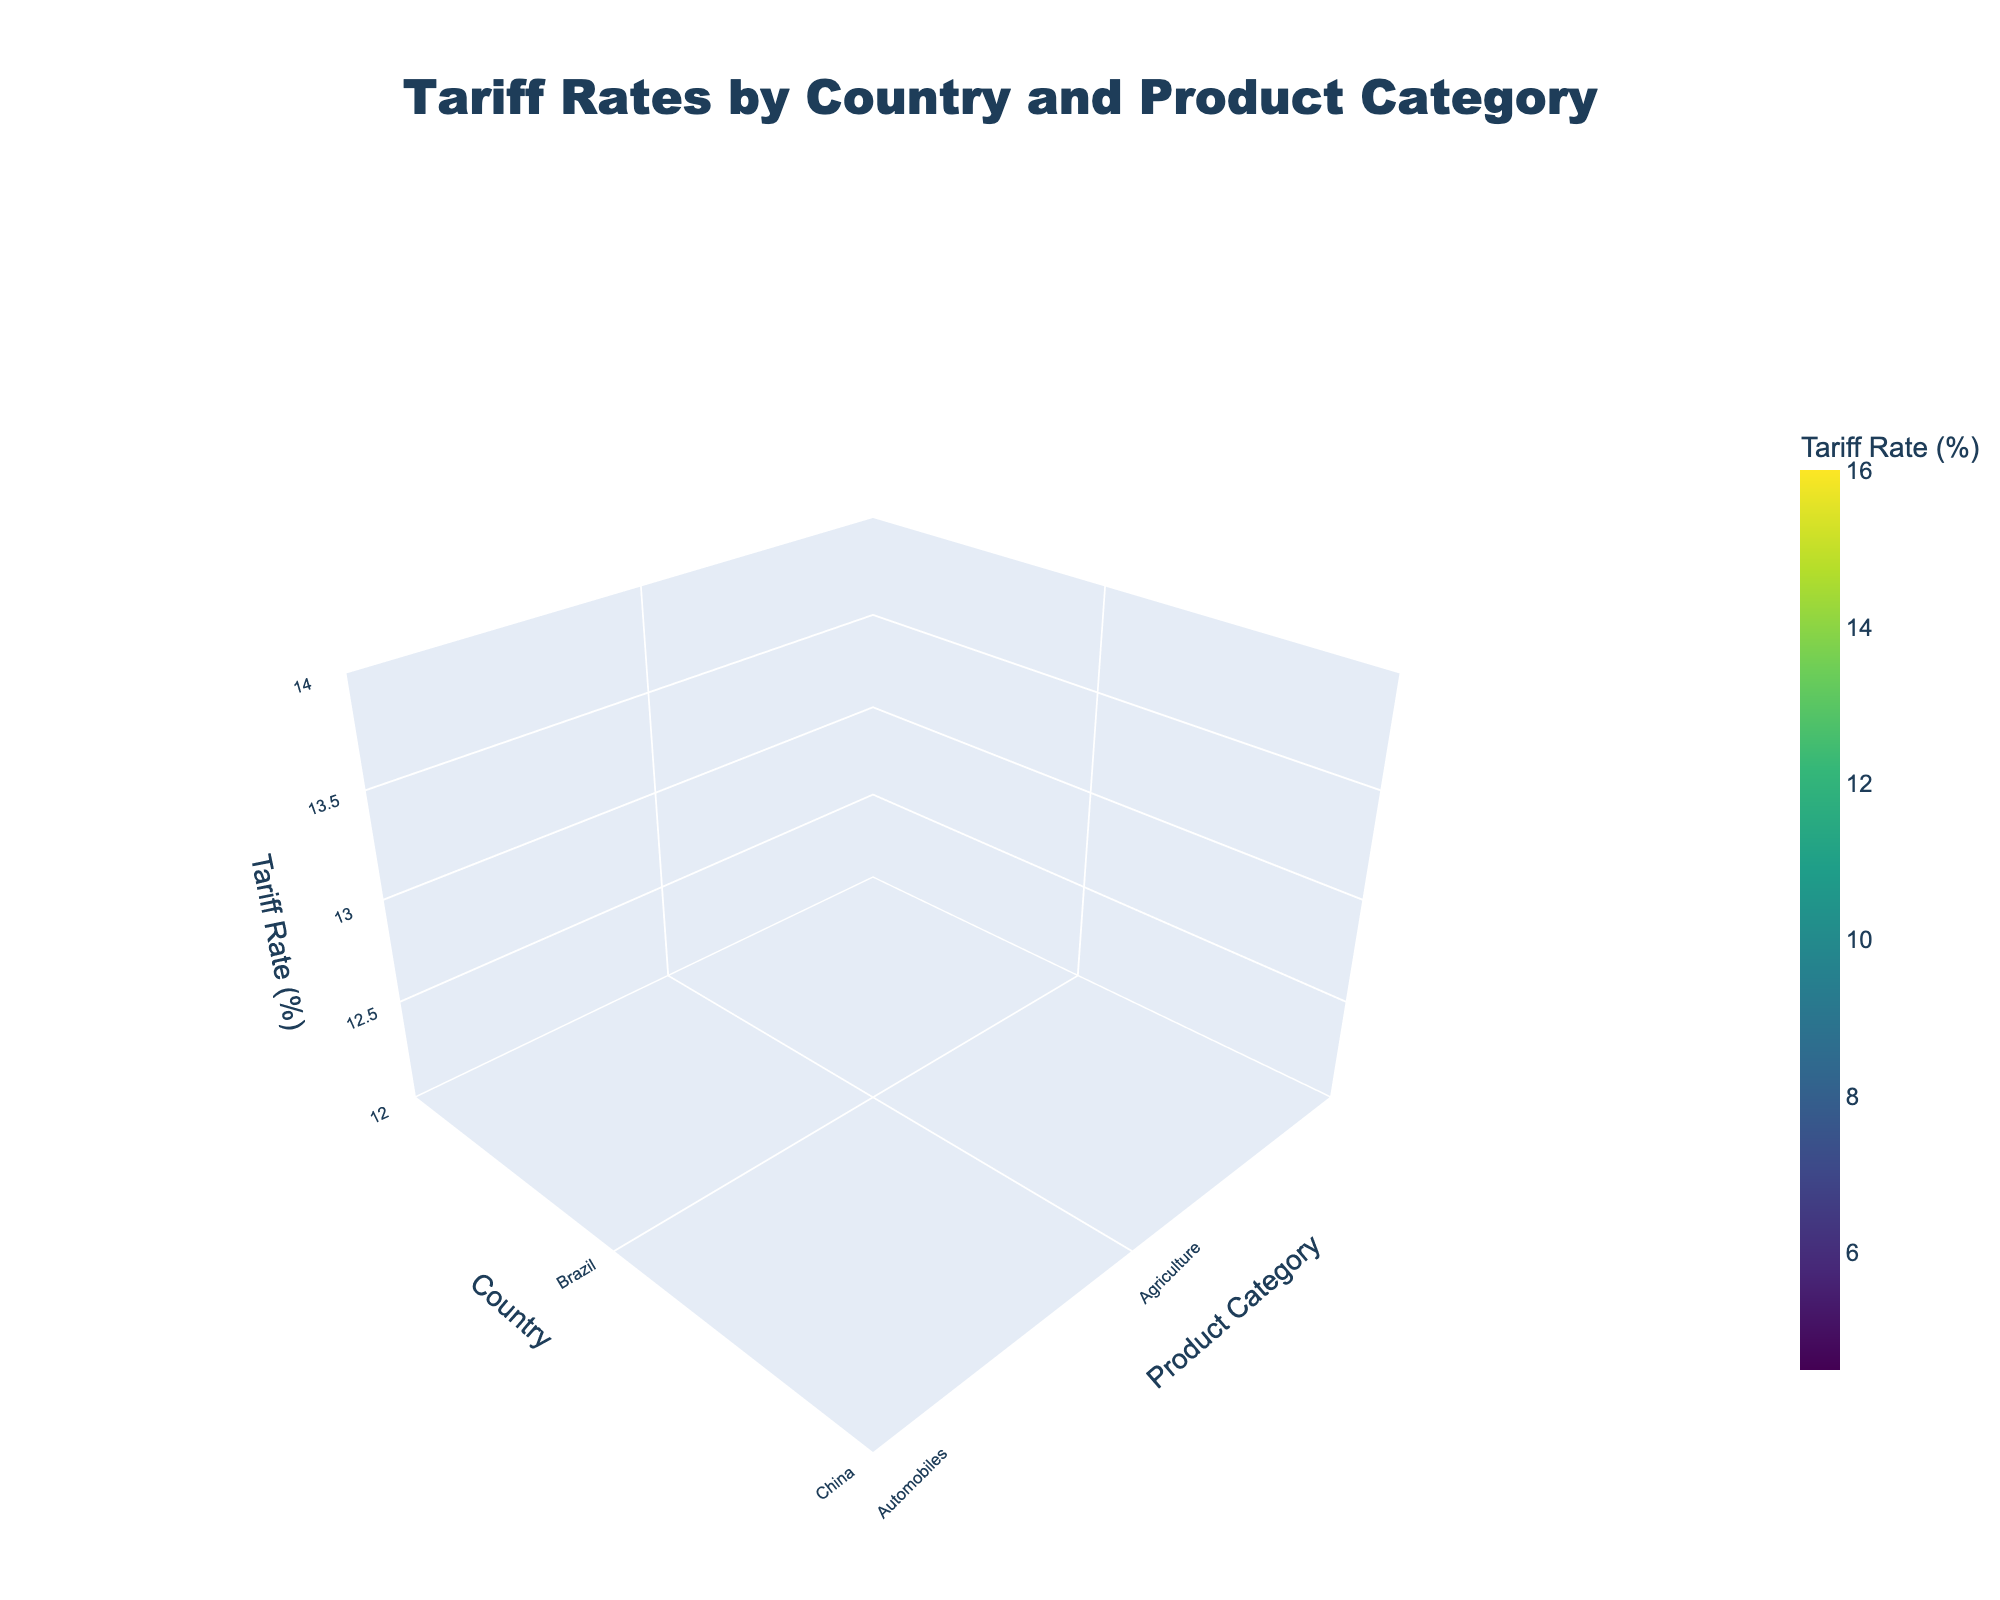What is the title of the 3D surface plot? The title is displayed at the top center of the plot. It reads "Tariff Rates by Country and Product Category."
Answer: Tariff Rates by Country and Product Category What are the axes labels and their positions? The axes labels are: 'Product Category' on the x-axis, 'Country' on the y-axis, and 'Tariff Rate (%)' on the z-axis. The labels are aligned at the ends of their respective axes.
Answer: Product Category (x-axis), Country (y-axis), Tariff Rate (%) (z-axis) Which country has the highest tariff rate for Textiles? Look at the z-values for the Textiles category on the x-axis and identify the maximum peak. Brazil has the highest tariff rate of 16.0%.
Answer: Brazil What is the average tariff rate for Electronics across all countries? To find the average, check the z-values for the Electronics category, sum them up (15.5+7.0+11.0+9.0+13.5) and divide by the number of countries. The sum is 56.0 and the number of countries is 5, so the average is 56.0/5.
Answer: 11.2% Which product category has the lowest average tariff rate? Calculate the average tariff rate for each product category by summing up their z-values and dividing by the number of countries providing tariffs for that category, then compare the averages. Machinery has the lowest average rate: (8.5+5.5+4.5+10.5+12.5)/5 = 8.3%.
Answer: Machinery How do the tariff rates for Automobiles compare between Japan and South Korea? Identify the z-values for Automobiles for Japan and South Korea and compare them. Japan has a tariff rate of 10.0%, and South Korea has 8.0%. Japan’s rate is higher.
Answer: Japan's rate is higher Which country has the highest overall average tariff rate across all product categories? Calculate the average tariff rate for each country by summing their individual product category tariffs and dividing by the number of categories. Brazil has the highest overall: (13.0+12.5+16.0)/3 = 13.83%.
Answer: Brazil What is the range of tariff rates for Agriculture products? Identify the maximum and minimum tariff rates for Agriculture among all countries. Maximum is 15.0% (Vietnam) and minimum is 11.5% (Mexico). The range is 15.0 - 11.5 = 3.5%.
Answer: 3.5% 